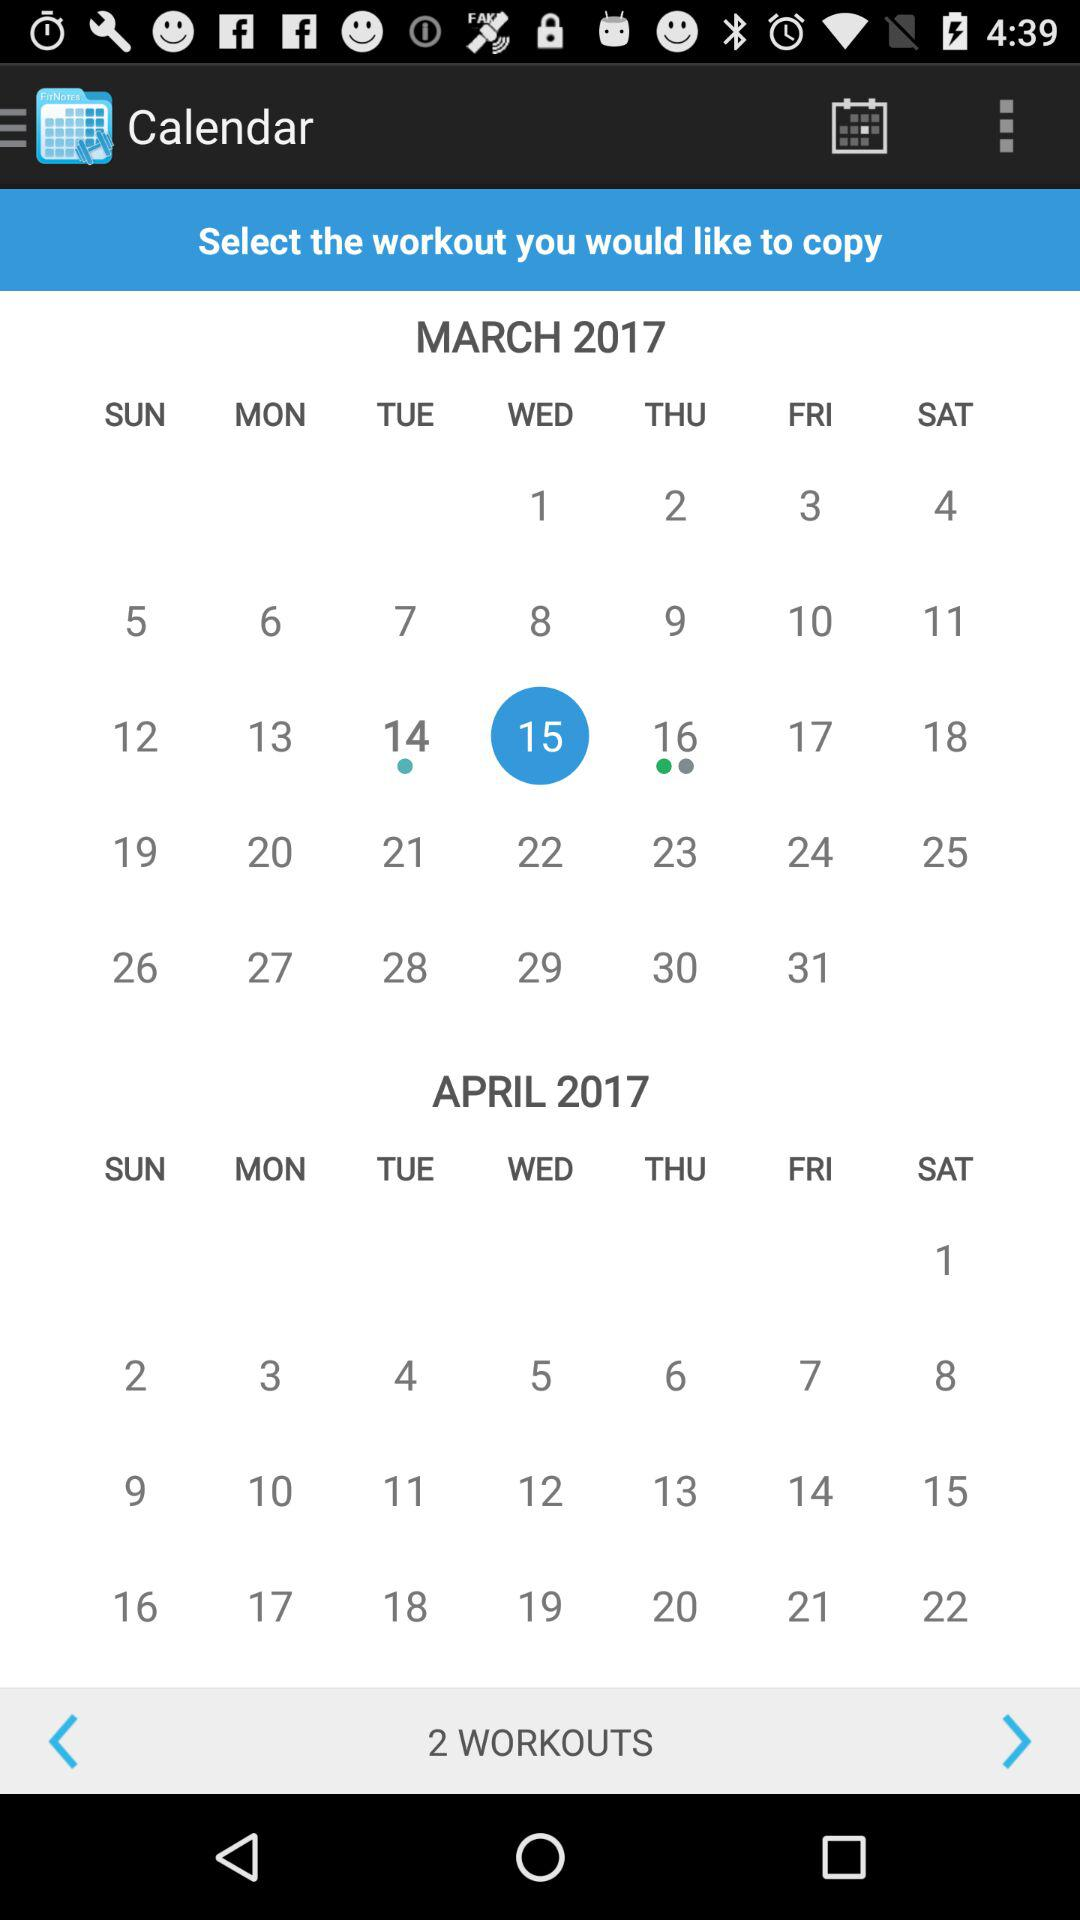Which date is selected for workout? What is the date today? The date is Wednesday, March 15, 2017. 